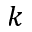<formula> <loc_0><loc_0><loc_500><loc_500>k</formula> 